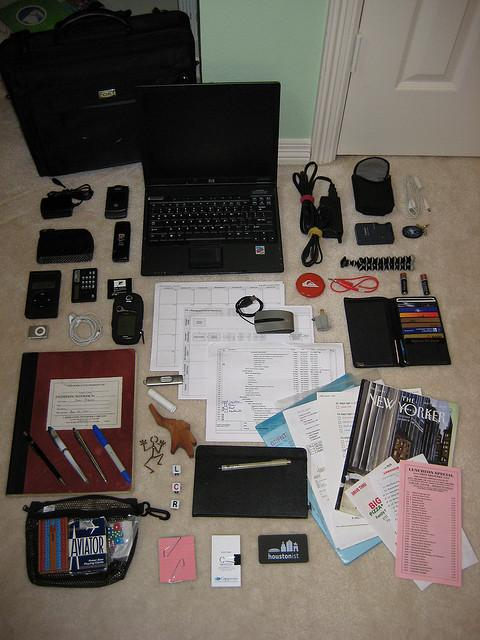How many laptops do you see? Please explain your reasoning. one. There is one. 